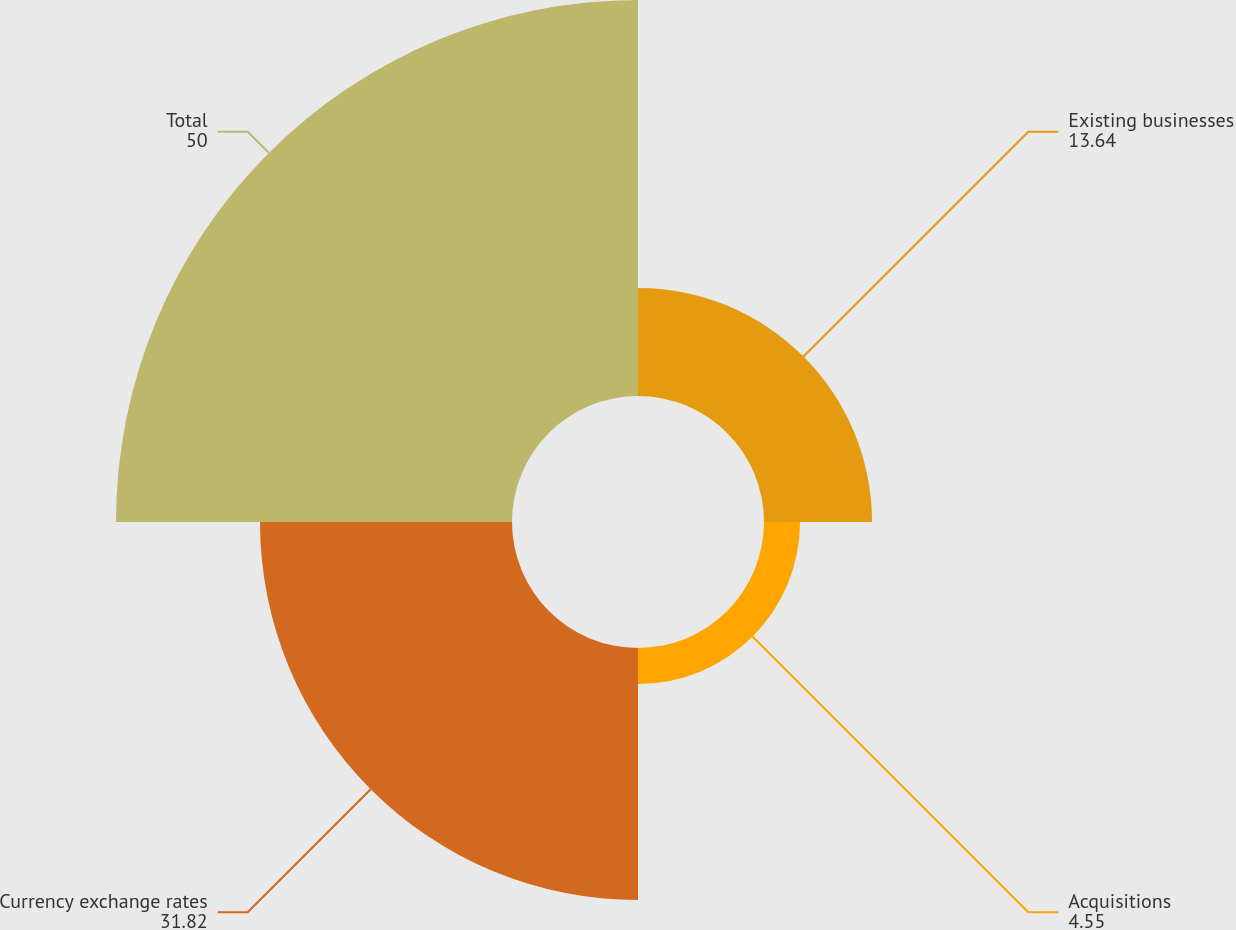Convert chart to OTSL. <chart><loc_0><loc_0><loc_500><loc_500><pie_chart><fcel>Existing businesses<fcel>Acquisitions<fcel>Currency exchange rates<fcel>Total<nl><fcel>13.64%<fcel>4.55%<fcel>31.82%<fcel>50.0%<nl></chart> 